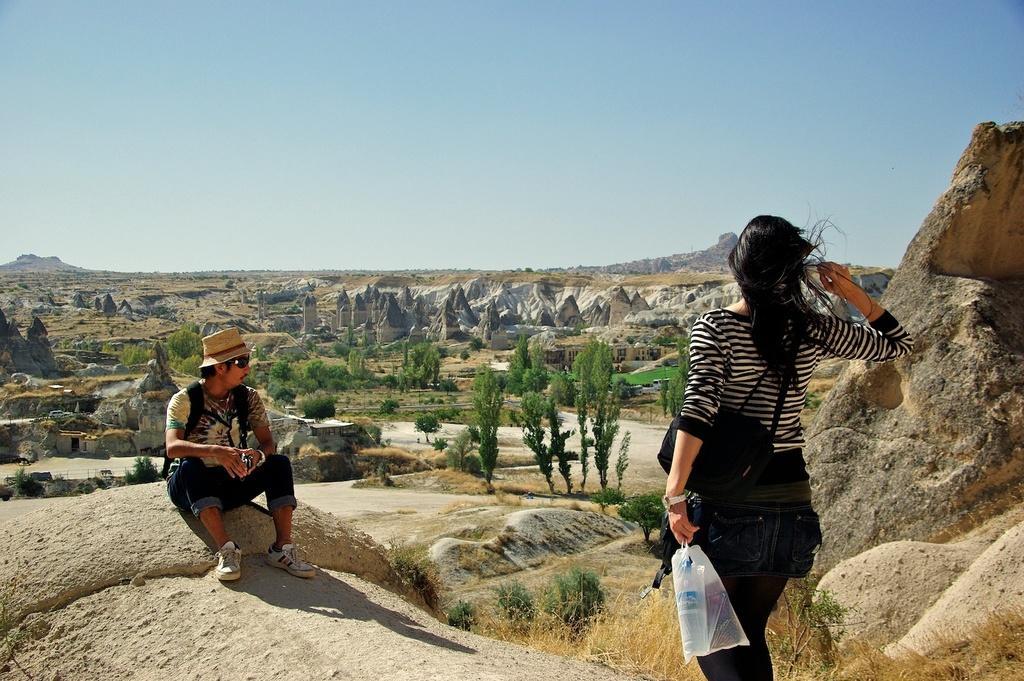Could you give a brief overview of what you see in this image? In this image I can see a person standing wearing black and white shirt, black pant and holding a cover, in front I can see the other person sitting, at the back I can see trees in green color, few mountains and sky in blue color. 